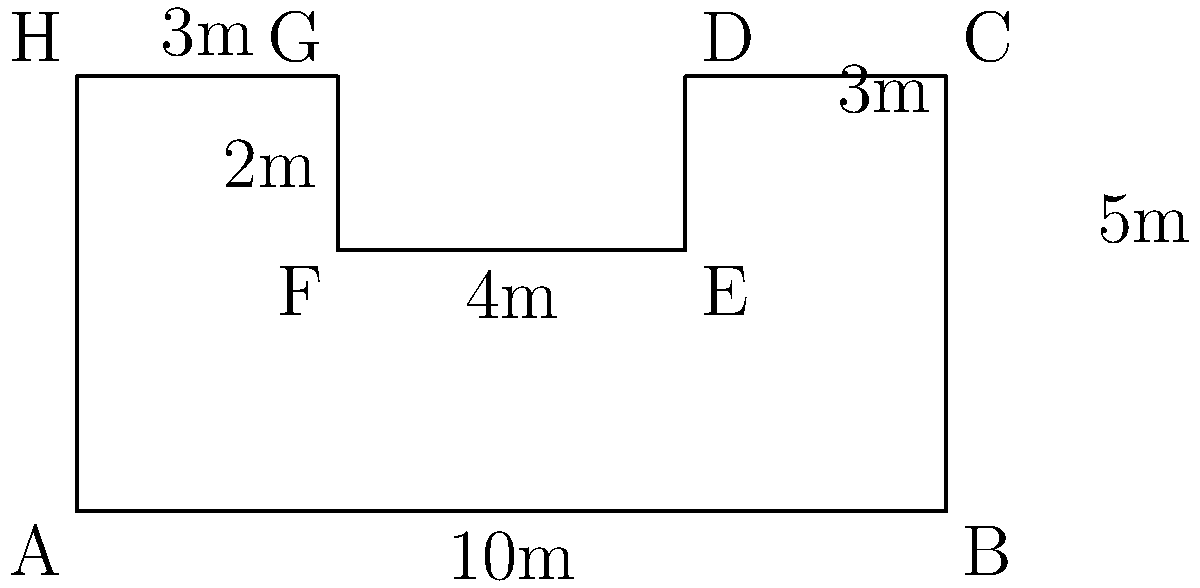As a regional manager for a coffee chain, you're overseeing the renovation of one of your stores. The floor plan of the coffee shop has an irregular shape, as shown in the diagram. Calculate the perimeter of the coffee shop floor in meters. To calculate the perimeter, we need to sum up the lengths of all sides of the irregular shape:

1. Side AB: $10$ m
2. Side BC: $5$ m
3. Side CD: $3$ m
4. Side DE: $2$ m
5. Side EF: $4$ m
6. Side FG: $2$ m
7. Side GH: $3$ m
8. Side HA: $5$ m

Now, let's add all these lengths:

$$\text{Perimeter} = 10 + 5 + 3 + 2 + 4 + 2 + 3 + 5 = 34\text{ m}$$

Therefore, the perimeter of the coffee shop floor is 34 meters.
Answer: 34 m 